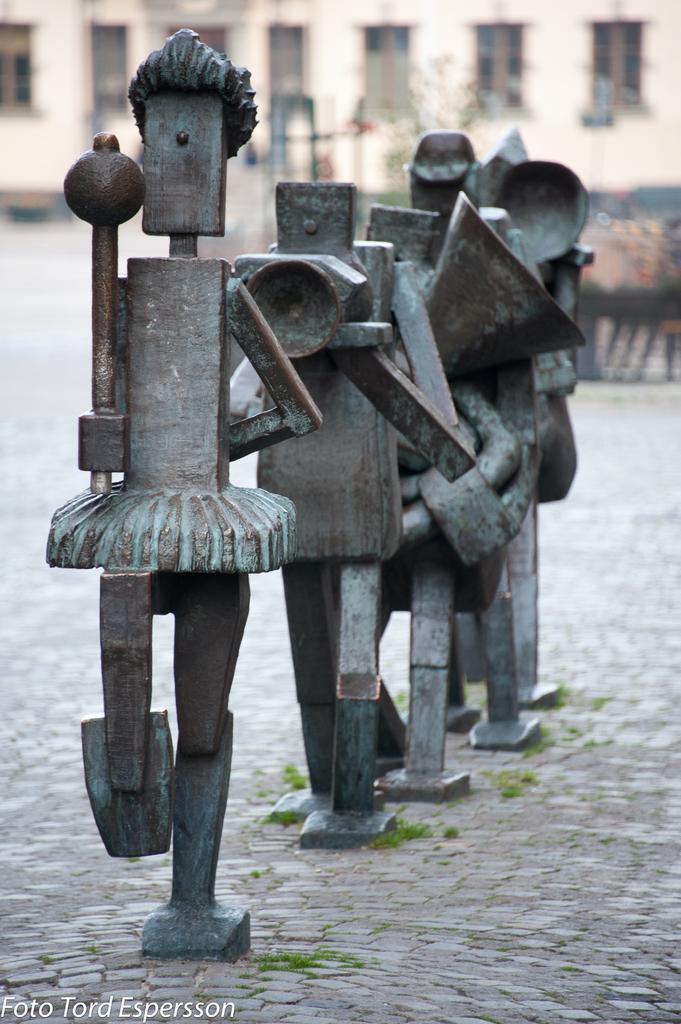Describe this image in one or two sentences. In the foreground of this image, there are metal statues on a pavement. In the background, there is a building. 